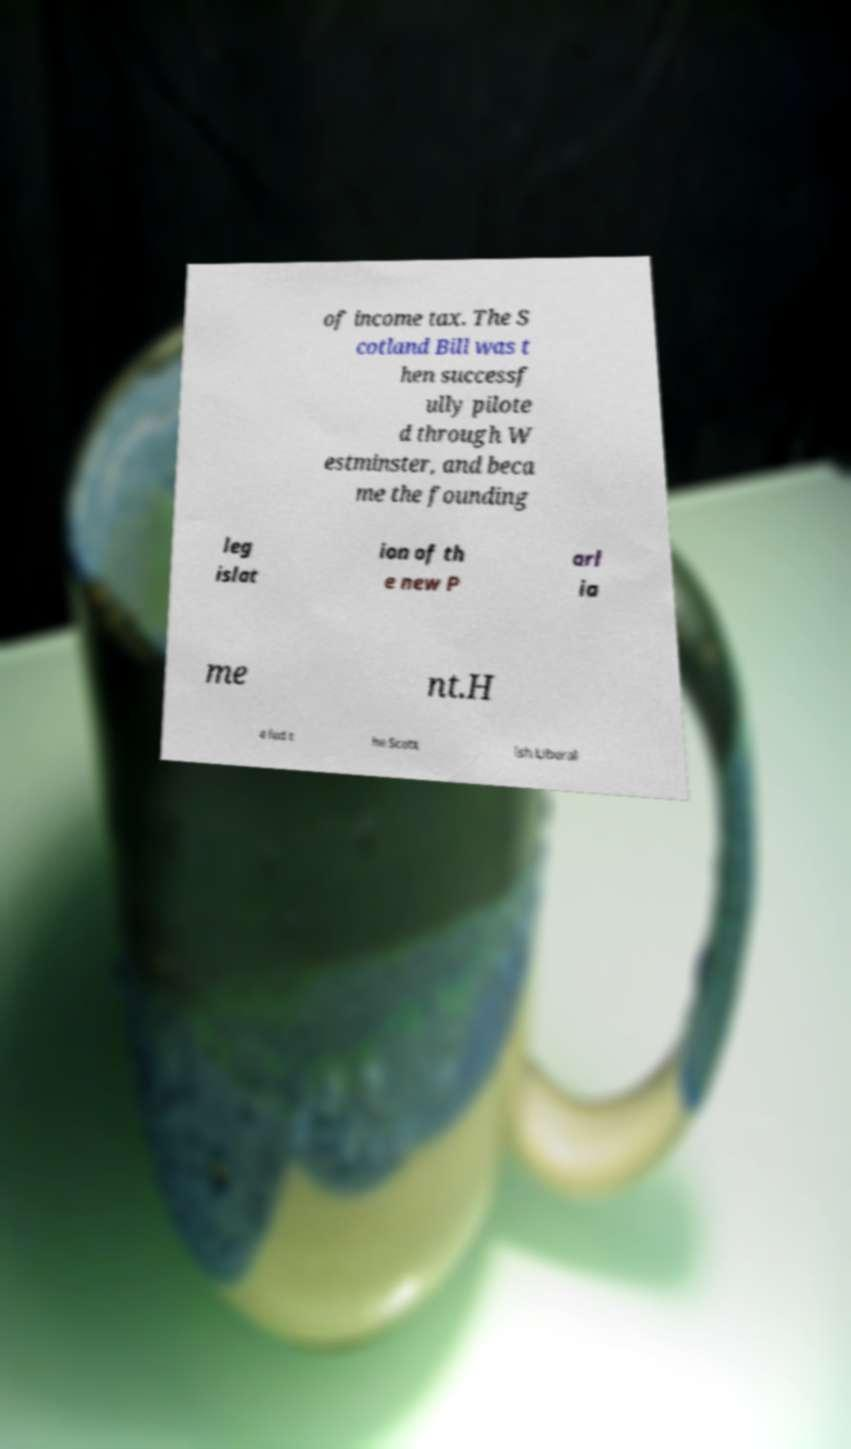Could you assist in decoding the text presented in this image and type it out clearly? of income tax. The S cotland Bill was t hen successf ully pilote d through W estminster, and beca me the founding leg islat ion of th e new P arl ia me nt.H e led t he Scott ish Liberal 